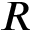<formula> <loc_0><loc_0><loc_500><loc_500>R</formula> 